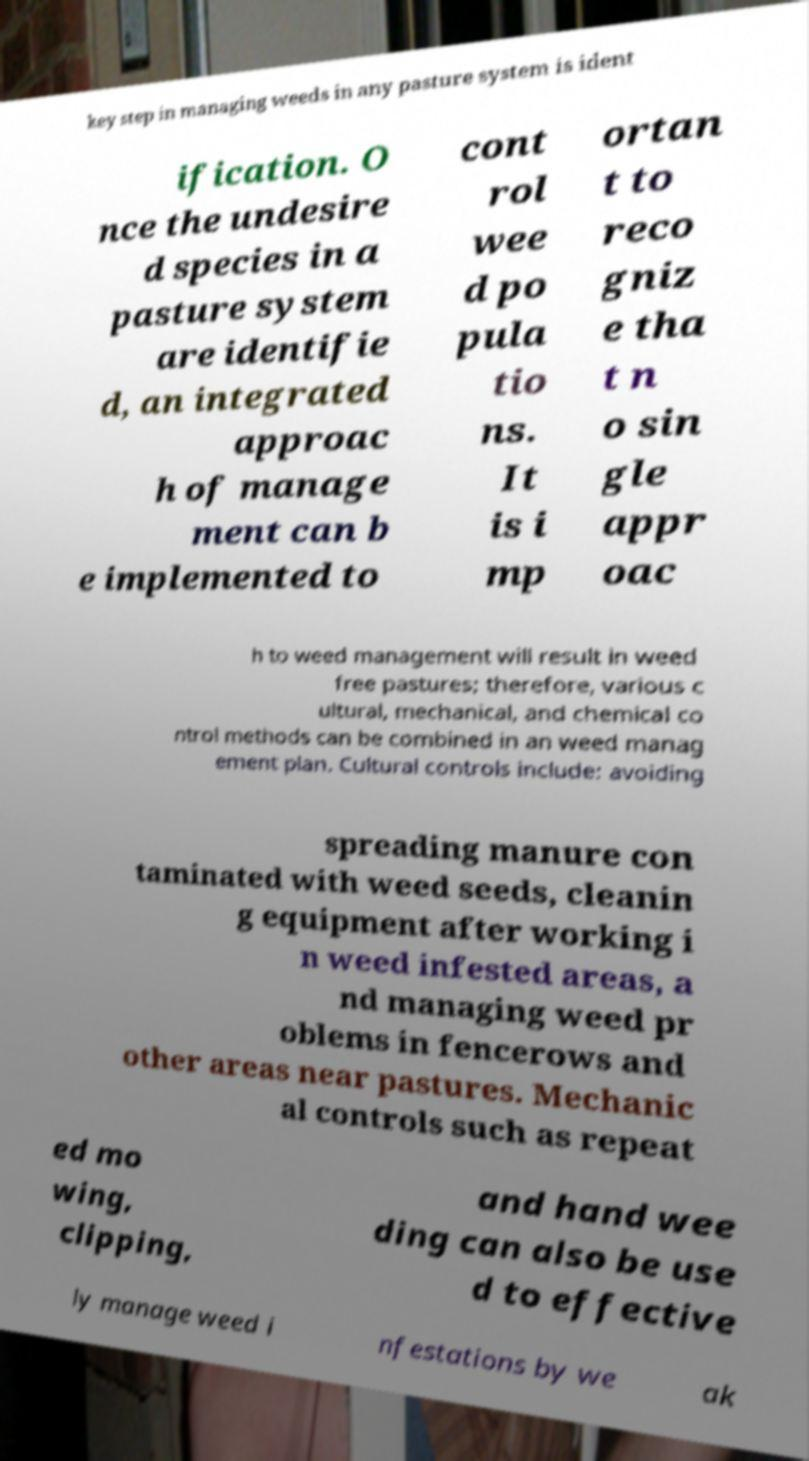Could you assist in decoding the text presented in this image and type it out clearly? key step in managing weeds in any pasture system is ident ification. O nce the undesire d species in a pasture system are identifie d, an integrated approac h of manage ment can b e implemented to cont rol wee d po pula tio ns. It is i mp ortan t to reco gniz e tha t n o sin gle appr oac h to weed management will result in weed free pastures; therefore, various c ultural, mechanical, and chemical co ntrol methods can be combined in an weed manag ement plan. Cultural controls include: avoiding spreading manure con taminated with weed seeds, cleanin g equipment after working i n weed infested areas, a nd managing weed pr oblems in fencerows and other areas near pastures. Mechanic al controls such as repeat ed mo wing, clipping, and hand wee ding can also be use d to effective ly manage weed i nfestations by we ak 